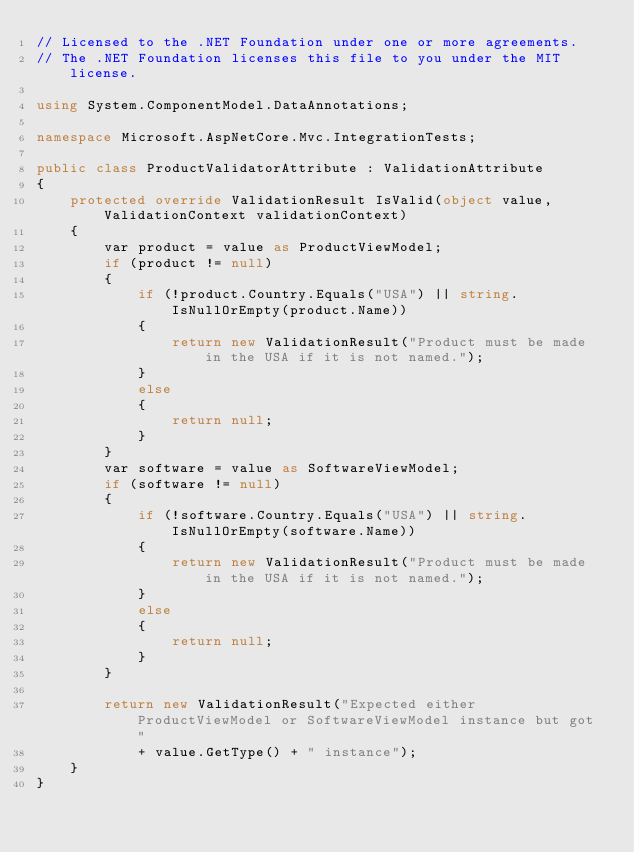<code> <loc_0><loc_0><loc_500><loc_500><_C#_>// Licensed to the .NET Foundation under one or more agreements.
// The .NET Foundation licenses this file to you under the MIT license.

using System.ComponentModel.DataAnnotations;

namespace Microsoft.AspNetCore.Mvc.IntegrationTests;

public class ProductValidatorAttribute : ValidationAttribute
{
    protected override ValidationResult IsValid(object value, ValidationContext validationContext)
    {
        var product = value as ProductViewModel;
        if (product != null)
        {
            if (!product.Country.Equals("USA") || string.IsNullOrEmpty(product.Name))
            {
                return new ValidationResult("Product must be made in the USA if it is not named.");
            }
            else
            {
                return null;
            }
        }
        var software = value as SoftwareViewModel;
        if (software != null)
        {
            if (!software.Country.Equals("USA") || string.IsNullOrEmpty(software.Name))
            {
                return new ValidationResult("Product must be made in the USA if it is not named.");
            }
            else
            {
                return null;
            }
        }

        return new ValidationResult("Expected either ProductViewModel or SoftwareViewModel instance but got "
            + value.GetType() + " instance");
    }
}
</code> 